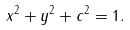<formula> <loc_0><loc_0><loc_500><loc_500>x ^ { 2 } + y ^ { 2 } + c ^ { 2 } = 1 .</formula> 